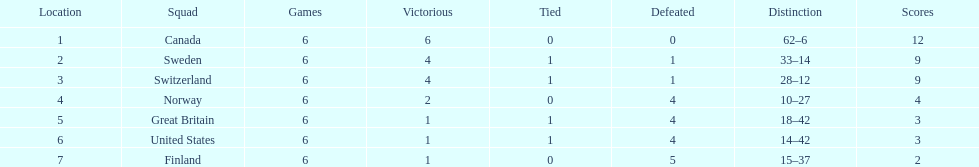How many teams won 6 matches? 1. Would you mind parsing the complete table? {'header': ['Location', 'Squad', 'Games', 'Victorious', 'Tied', 'Defeated', 'Distinction', 'Scores'], 'rows': [['1', 'Canada', '6', '6', '0', '0', '62–6', '12'], ['2', 'Sweden', '6', '4', '1', '1', '33–14', '9'], ['3', 'Switzerland', '6', '4', '1', '1', '28–12', '9'], ['4', 'Norway', '6', '2', '0', '4', '10–27', '4'], ['5', 'Great Britain', '6', '1', '1', '4', '18–42', '3'], ['6', 'United States', '6', '1', '1', '4', '14–42', '3'], ['7', 'Finland', '6', '1', '0', '5', '15–37', '2']]} 